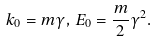<formula> <loc_0><loc_0><loc_500><loc_500>k _ { 0 } = m \gamma , \, E _ { 0 } = \frac { m } { 2 } \gamma ^ { 2 } .</formula> 